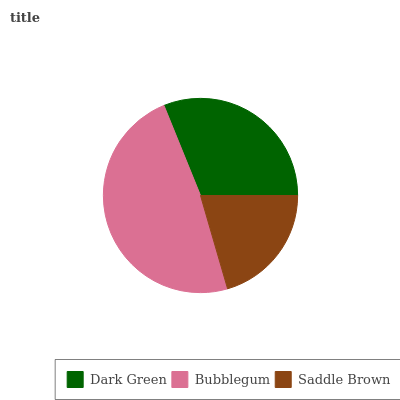Is Saddle Brown the minimum?
Answer yes or no. Yes. Is Bubblegum the maximum?
Answer yes or no. Yes. Is Bubblegum the minimum?
Answer yes or no. No. Is Saddle Brown the maximum?
Answer yes or no. No. Is Bubblegum greater than Saddle Brown?
Answer yes or no. Yes. Is Saddle Brown less than Bubblegum?
Answer yes or no. Yes. Is Saddle Brown greater than Bubblegum?
Answer yes or no. No. Is Bubblegum less than Saddle Brown?
Answer yes or no. No. Is Dark Green the high median?
Answer yes or no. Yes. Is Dark Green the low median?
Answer yes or no. Yes. Is Saddle Brown the high median?
Answer yes or no. No. Is Saddle Brown the low median?
Answer yes or no. No. 